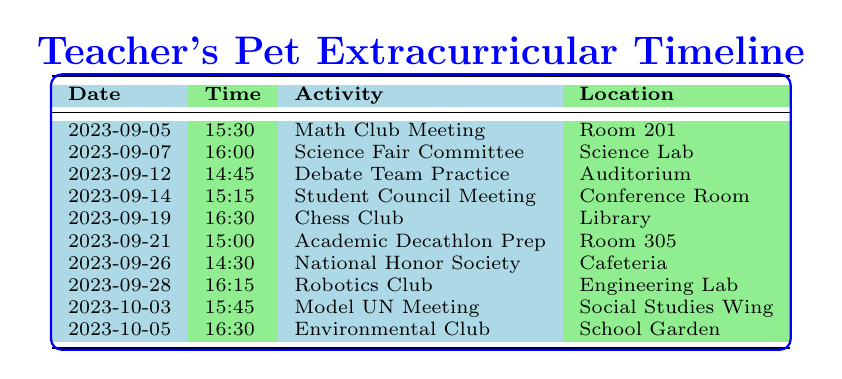What is the location of the Robotics Club meeting? The table lists the Robotics Club meeting under the column for location, which specifies "Engineering Lab". Therefore, the location of the Robotics Club meeting is Engineering Lab.
Answer: Engineering Lab How many activities are scheduled for September 2023? Counting the rows for September, there are 8 activities listed, which include Math Club Meeting, Science Fair Committee, Debate Team Practice, Student Council Meeting, Chess Club, Academic Decathlon Prep, National Honor Society, and Robotics Club.
Answer: 8 Was there a meeting for the Debate Team in September? The table lists one activity for the Debate Team, which took place on September 12. Therefore, the answer is yes.
Answer: Yes What is the time for the Environmental Club meeting? The Environmental Club meeting is scheduled for October 5 at 16:30, as indicated in the time column.
Answer: 16:30 How many meetings take place in the Cafeteria? The table shows one meeting scheduled in the Cafeteria, which is the National Honor Society meeting on September 26.
Answer: 1 What is the average time of meetings in September? The meeting times in September are as follows: 15:30, 16:00, 14:45, 15:15, 16:30, 15:00, 14:30. Converting these times into minutes since midnight gives 930, 960, 885, 915, 990, 900, 870 minutes. The total is 6345 minutes for 7 meetings, so the average time in minutes is 6345/7 = 905.71, which converts back to approximately 15:05.
Answer: 15:05 Is the Student Council Meeting scheduled before the Chess Club? Checking the dates, the Student Council Meeting is on September 14 and the Chess Club Meeting is on September 19. Since September 14 is before September 19, the answer is yes.
Answer: Yes Which activity is scheduled right before the Debate Team Practice? The table shows that the Debate Team Practice occurs on September 12, and the previous activity listed is the Science Fair Committee on September 7. Therefore, the activity right before the Debate Team Practice is the Science Fair Committee.
Answer: Science Fair Committee 